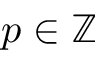Convert formula to latex. <formula><loc_0><loc_0><loc_500><loc_500>p \in \mathbb { Z }</formula> 